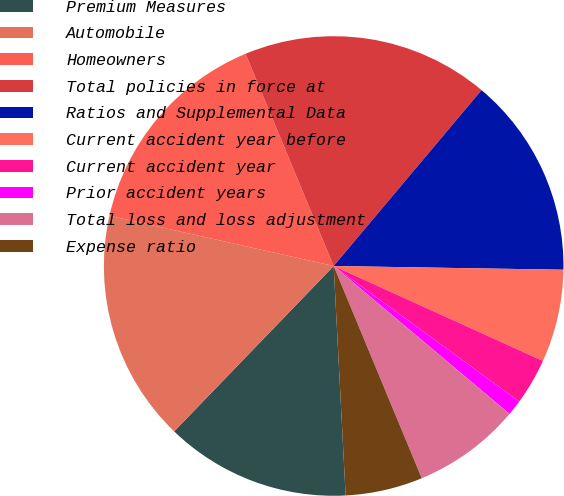<chart> <loc_0><loc_0><loc_500><loc_500><pie_chart><fcel>Premium Measures<fcel>Automobile<fcel>Homeowners<fcel>Total policies in force at<fcel>Ratios and Supplemental Data<fcel>Current accident year before<fcel>Current accident year<fcel>Prior accident years<fcel>Total loss and loss adjustment<fcel>Expense ratio<nl><fcel>13.04%<fcel>16.3%<fcel>15.22%<fcel>17.39%<fcel>14.13%<fcel>6.52%<fcel>3.26%<fcel>1.09%<fcel>7.61%<fcel>5.43%<nl></chart> 